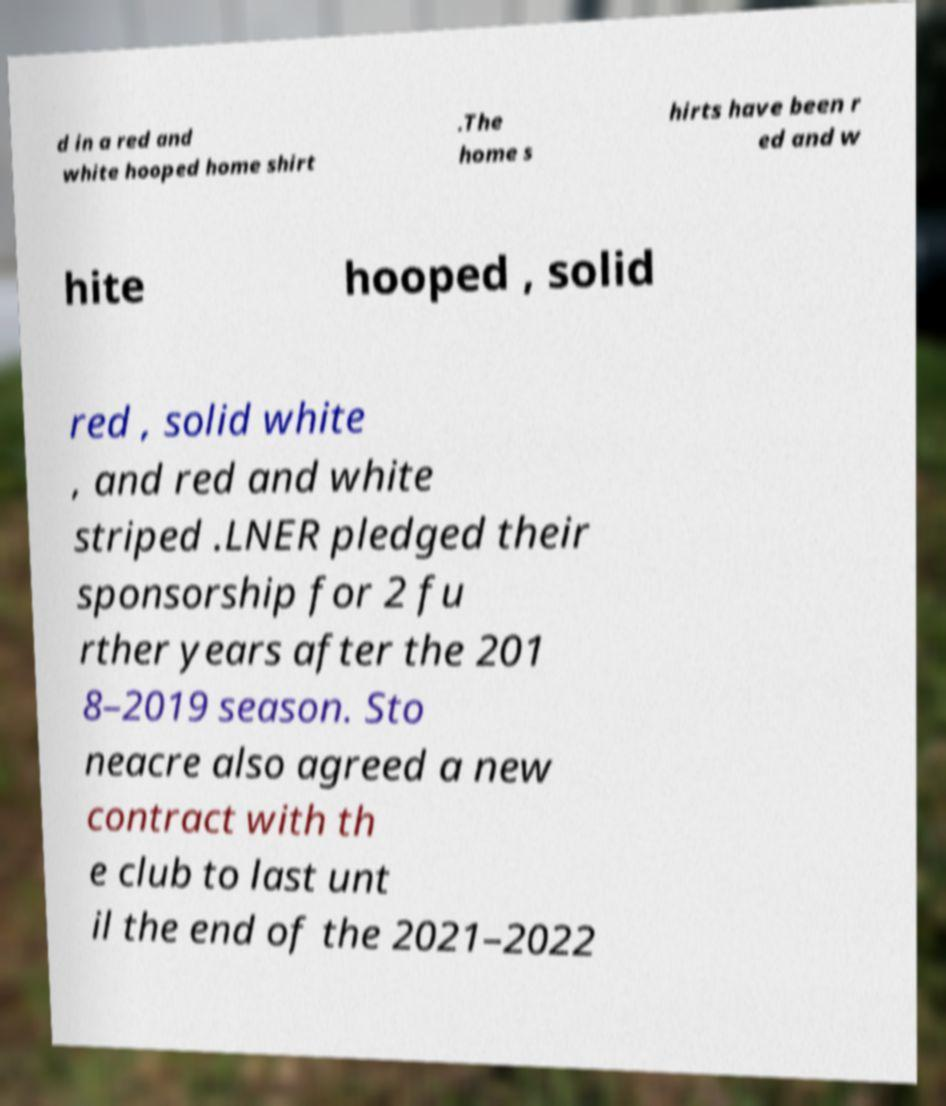Please identify and transcribe the text found in this image. d in a red and white hooped home shirt .The home s hirts have been r ed and w hite hooped , solid red , solid white , and red and white striped .LNER pledged their sponsorship for 2 fu rther years after the 201 8–2019 season. Sto neacre also agreed a new contract with th e club to last unt il the end of the 2021–2022 